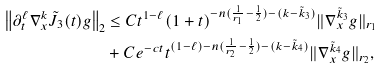Convert formula to latex. <formula><loc_0><loc_0><loc_500><loc_500>\left \| \partial _ { t } ^ { \ell } \nabla _ { x } ^ { k } \tilde { J } _ { 3 } ( t ) g \right \| _ { 2 } & \leq C t ^ { 1 - \ell } ( 1 + t ) ^ { - n ( \frac { 1 } { r _ { 1 } } - \frac { 1 } { 2 } ) - ( k - \tilde { k } _ { 3 } ) } \| \nabla ^ { \tilde { k } _ { 3 } } _ { x } g \| _ { r _ { 1 } } \\ & + C e ^ { - c t } t ^ { ( 1 - \ell ) - n ( \frac { 1 } { r _ { 2 } } - \frac { 1 } { 2 } ) - ( k - \tilde { k } _ { 4 } ) } \| \nabla ^ { \tilde { k } _ { 4 } } _ { x } g \| _ { r _ { 2 } } ,</formula> 